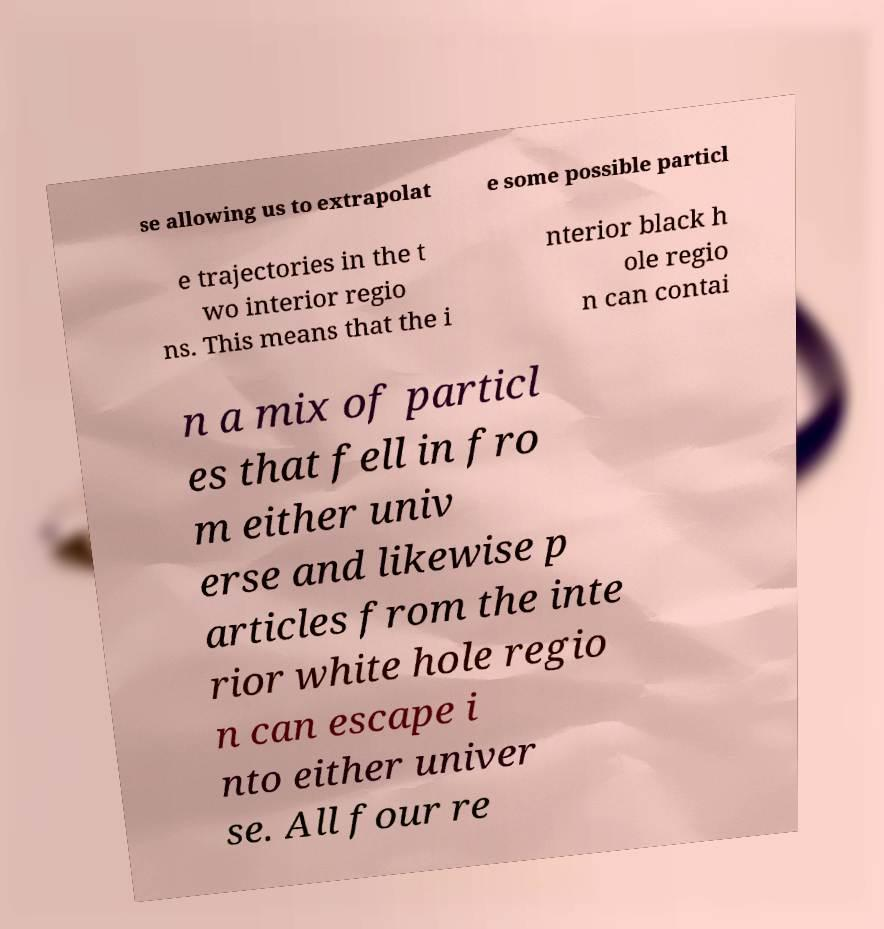Please read and relay the text visible in this image. What does it say? se allowing us to extrapolat e some possible particl e trajectories in the t wo interior regio ns. This means that the i nterior black h ole regio n can contai n a mix of particl es that fell in fro m either univ erse and likewise p articles from the inte rior white hole regio n can escape i nto either univer se. All four re 